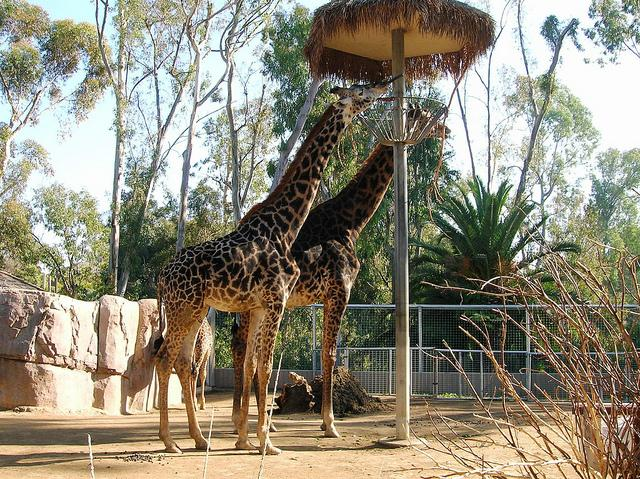What kind of fencing encloses these giraffes in the zoo?

Choices:
A) stone
B) chain link
C) wooden
D) electrified wire chain link 